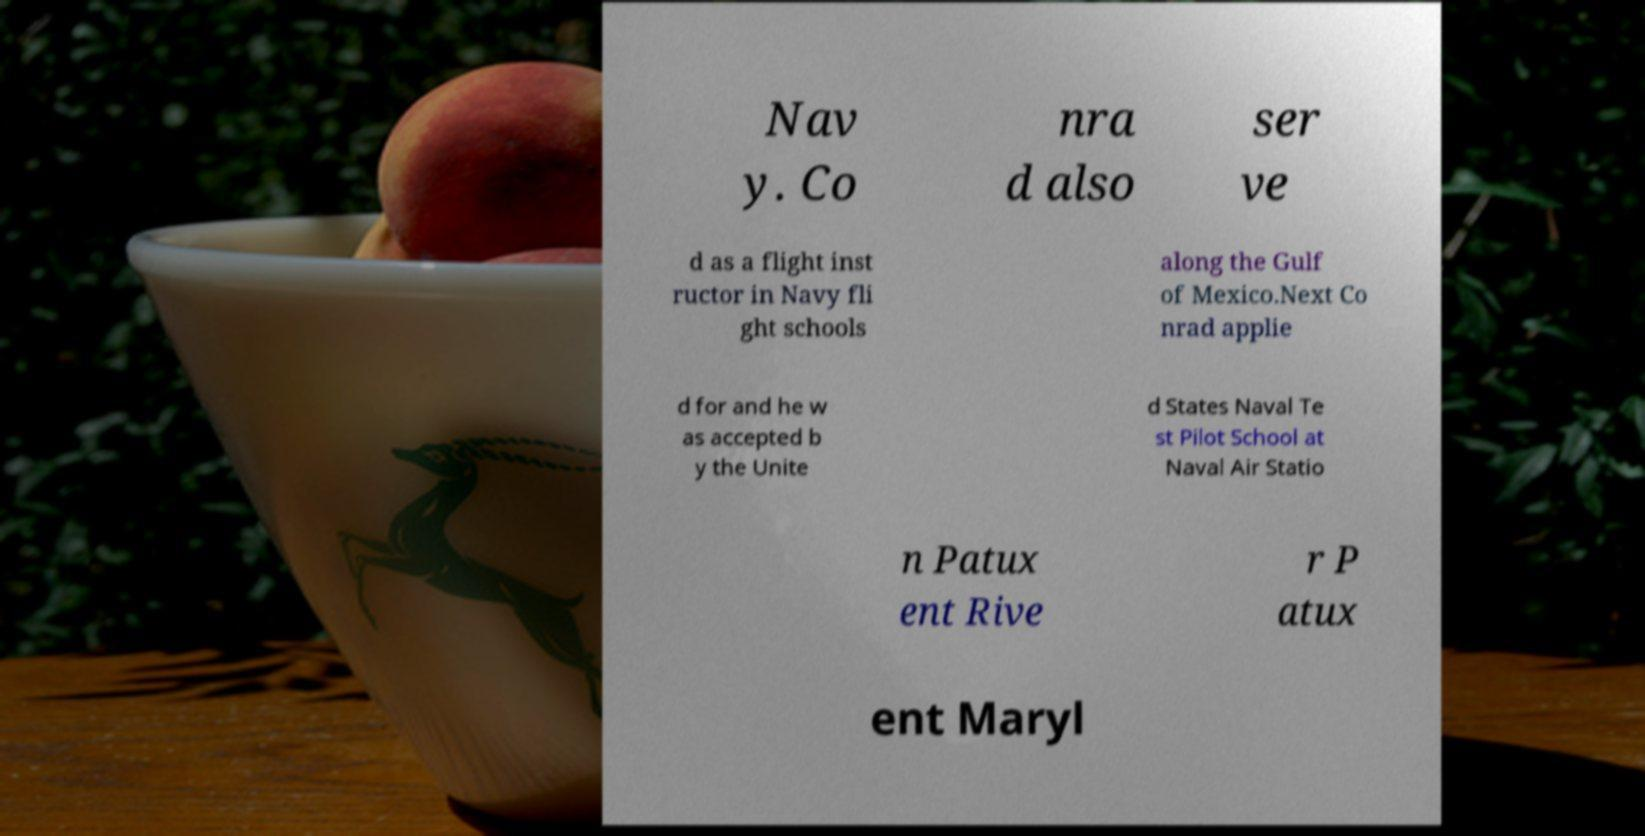Could you extract and type out the text from this image? Nav y. Co nra d also ser ve d as a flight inst ructor in Navy fli ght schools along the Gulf of Mexico.Next Co nrad applie d for and he w as accepted b y the Unite d States Naval Te st Pilot School at Naval Air Statio n Patux ent Rive r P atux ent Maryl 